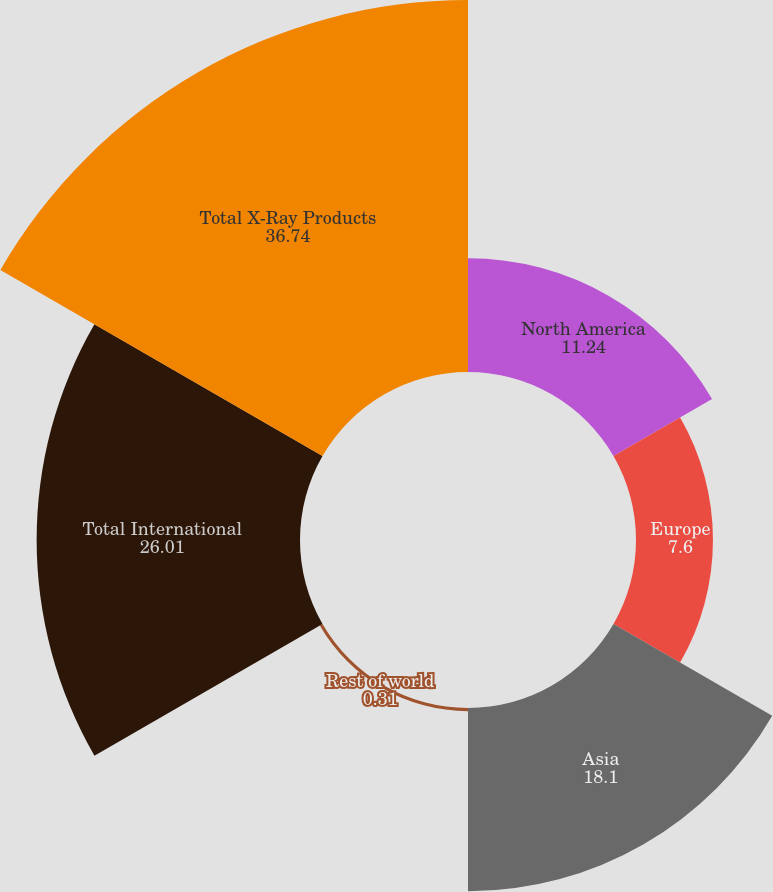Convert chart to OTSL. <chart><loc_0><loc_0><loc_500><loc_500><pie_chart><fcel>North America<fcel>Europe<fcel>Asia<fcel>Rest of world<fcel>Total International<fcel>Total X-Ray Products<nl><fcel>11.24%<fcel>7.6%<fcel>18.1%<fcel>0.31%<fcel>26.01%<fcel>36.74%<nl></chart> 